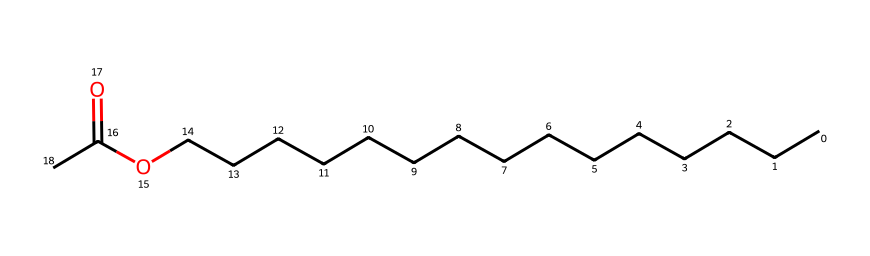What is the main functional group in this chemical? The chemical structure shows a carbonyl group (C=O) connected to an ester group due to the surrounding carbon chains and the ether oxygen, indicating that the main functional group is an ester.
Answer: ester How many carbon atoms are in this molecule? By analyzing the structure, the long carbon chain and the carbon in the carbonyl group, we can count a total of 15 carbon atoms present in this molecule.
Answer: 15 What is the significance of the long carbon chain in this chemical? The long carbon chain contributes to the hydrophobic characteristics of the molecules, making it effective in dissolving oil-based makeup products. This property enhances the solubility of various substances during makeup removal.
Answer: hydrophobic How many oxygen atoms are present in this compound? The structure indicates there are two oxygen atoms; one is part of the ester functional group and the other is bonded in the ether part of the molecule.
Answer: 2 What type of solvent is represented by this chemical? Given its composition, the chemical is classified as a non-polar solvent due to the predominance of carbon and hydrogen atoms in a long chain, which typically makes it effective for dissolving non-polar substances like oils in makeup.
Answer: non-polar What indicates the presence of an ester in the chemical's structure? The presence of the carbonyl group (C=O) adjacent to the ether oxygen (C-O) results in the characteristic structure of an ester, which defines its reactivity and properties related to makeup removal.
Answer: carbonyl and ether groups 